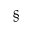Convert formula to latex. <formula><loc_0><loc_0><loc_500><loc_500>\S</formula> 